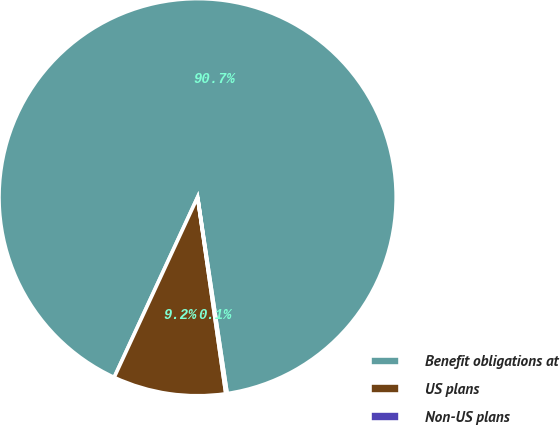<chart> <loc_0><loc_0><loc_500><loc_500><pie_chart><fcel>Benefit obligations at<fcel>US plans<fcel>Non-US plans<nl><fcel>90.71%<fcel>9.17%<fcel>0.11%<nl></chart> 